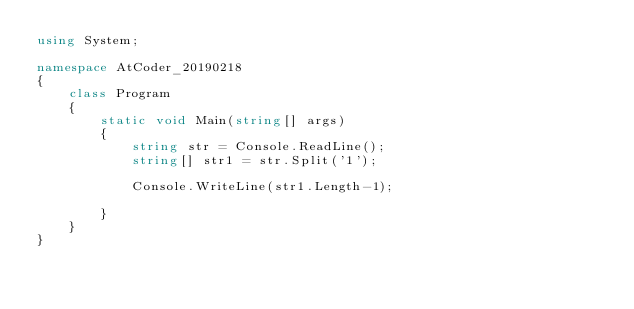<code> <loc_0><loc_0><loc_500><loc_500><_C#_>using System;

namespace AtCoder_20190218
{
    class Program
    {
        static void Main(string[] args)
        {
            string str = Console.ReadLine();
            string[] str1 = str.Split('1');
            
            Console.WriteLine(str1.Length-1);

        }
    }
}</code> 